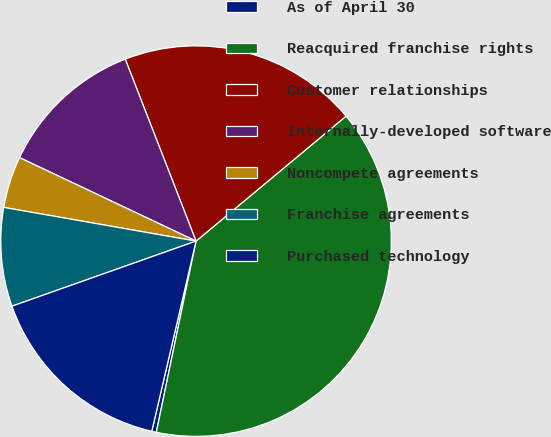Convert chart to OTSL. <chart><loc_0><loc_0><loc_500><loc_500><pie_chart><fcel>As of April 30<fcel>Reacquired franchise rights<fcel>Customer relationships<fcel>Internally-developed software<fcel>Noncompete agreements<fcel>Franchise agreements<fcel>Purchased technology<nl><fcel>0.38%<fcel>39.31%<fcel>19.85%<fcel>12.06%<fcel>4.27%<fcel>8.17%<fcel>15.95%<nl></chart> 